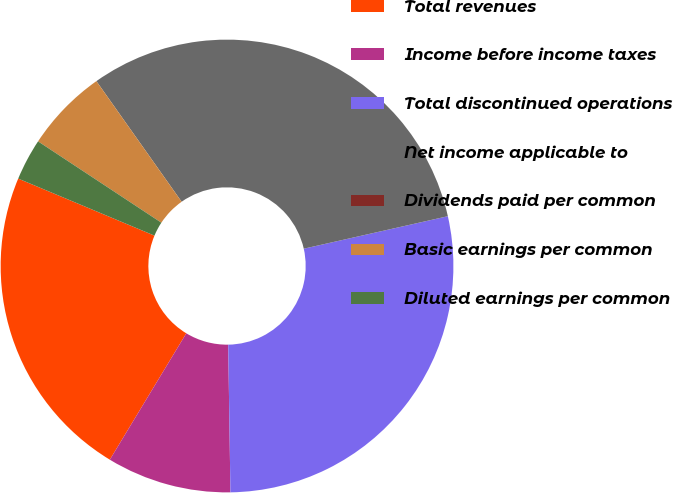<chart> <loc_0><loc_0><loc_500><loc_500><pie_chart><fcel>Total revenues<fcel>Income before income taxes<fcel>Total discontinued operations<fcel>Net income applicable to<fcel>Dividends paid per common<fcel>Basic earnings per common<fcel>Diluted earnings per common<nl><fcel>22.65%<fcel>8.9%<fcel>28.29%<fcel>31.26%<fcel>0.0%<fcel>5.93%<fcel>2.97%<nl></chart> 